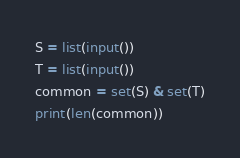Convert code to text. <code><loc_0><loc_0><loc_500><loc_500><_Python_>S = list(input())
T = list(input())
common = set(S) & set(T)
print(len(common))</code> 